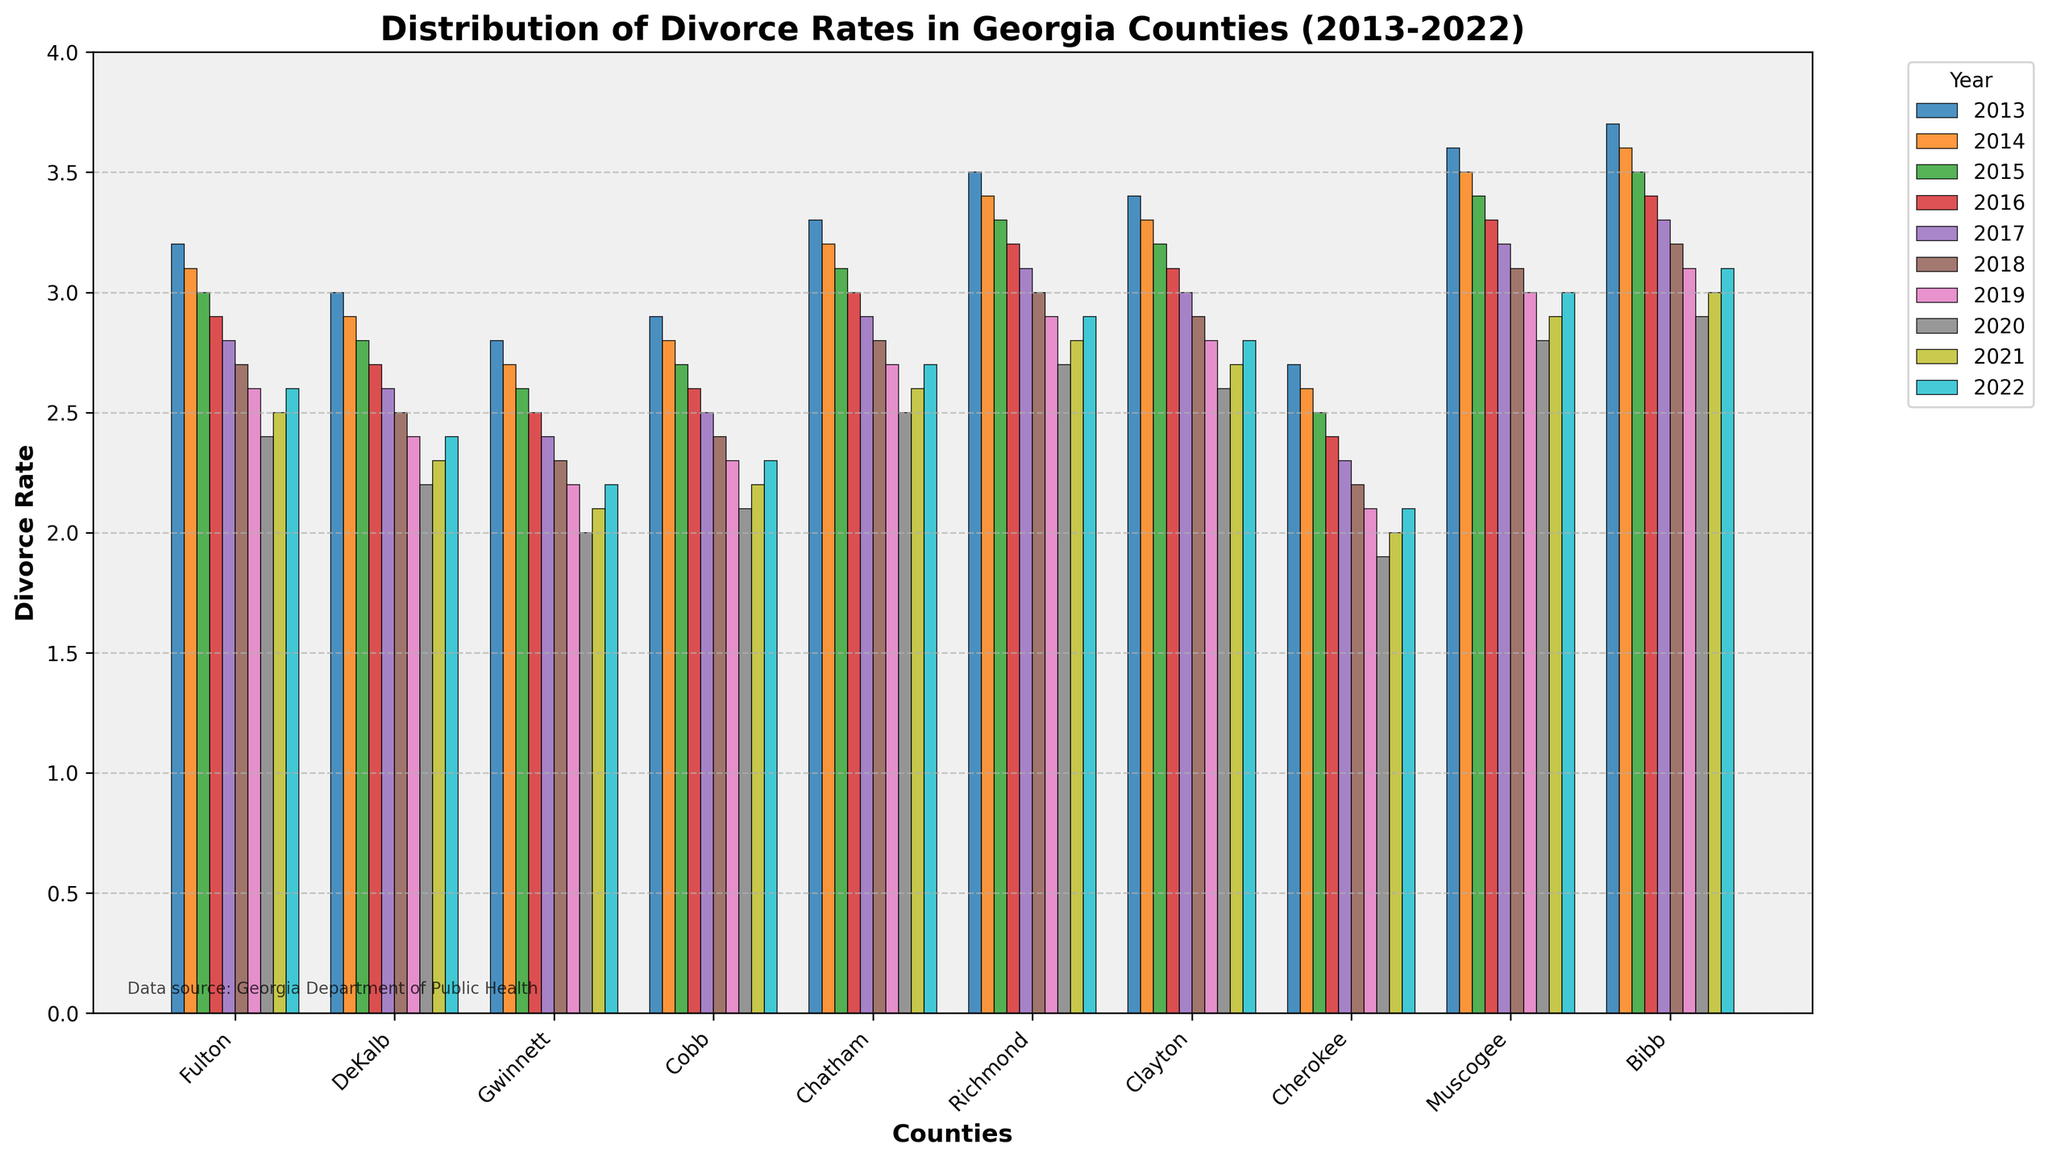What is the average divorce rate in Fulton County over the past decade? To find the average divorce rate in Fulton over the past decade (2013-2022), add up all the annual rates and divide by the number of years: (3.2 + 3.1 + 3.0 + 2.9 + 2.8 + 2.7 + 2.6 + 2.4 + 2.5 + 2.6) / 10.
Answer: 2.88 Which county had the highest divorce rate in 2022? Look at the height of the bars for 2022 and identify the county with the tallest bar. Bibb County has the highest bar in 2022 with a rate of 3.1.
Answer: Bibb How did the divorce rate in Richmond County change between 2013 and 2022? Subtract the divorce rate in Richmond County in 2013 from the rate in 2022: 2.9 - 3.5. This results in a change of -0.6.
Answer: -0.6 Which county showed the most significant decrease in divorce rates from 2013 to 2022? Calculate the difference in divorce rates for all counties from 2013 to 2022, and find the largest decrease: Fulton (0.6), DeKalb (0.6), Gwinnett (0.6), Cobb (0.6), Chatham (0.6), Richmond (0.6), Clayton (0.6), Cherokee (0.6), Muscogee (0.6), Bibb (0.6). They all showed a decrease of 0.6.
Answer: Equal Compare the divorce rates of Fulton County and DeKalb County in 2020. Which county had a lower rate? Look at the bars for 2020 for both Fulton and DeKalb counties and compare their heights. Fulton County had a rate of 2.4, and DeKalb County had a rate of 2.2.
Answer: DeKalb What trend can be observed in the divorce rates in Cobb County over the decade? Observe the general direction of the bars for Cobb County from 2013 to 2022. The bars are decreasing over time, indicating a downward trend.
Answer: Downward What is the median divorce rate in Muscogee County over the past decade? List the divorce rates of Muscogee County from 2013 to 2022 in order: [2.8, 2.9, 3.0, 3.1, 3.2, 3.3, 3.4, 3.5, 3.6]. The middle value (median) is 3.2.
Answer: 3.2 Which years did Chatham County have a higher divorce rate than the average divorce rate of DeKalb County for the same years? Calculate the average divorce rate for DeKalb County over the 10 years and compare each year for Chatham County: Average for DeKalb is 2.68. Chatham had higher rates in 2013 (3.3), 2014 (3.2), 2015 (3.1), 2016 (3.0), 2017 (2.9), and 2018 (2.8).
Answer: 2013-2018 Was the divorce rate higher in Clayton County or Cherokee County in 2019? Compare the heights of the bars for 2019 for both Clayton and Cherokee counties. Clayton County had a rate of 2.8, whereas Cherokee County had a rate of 2.1.
Answer: Clayton 